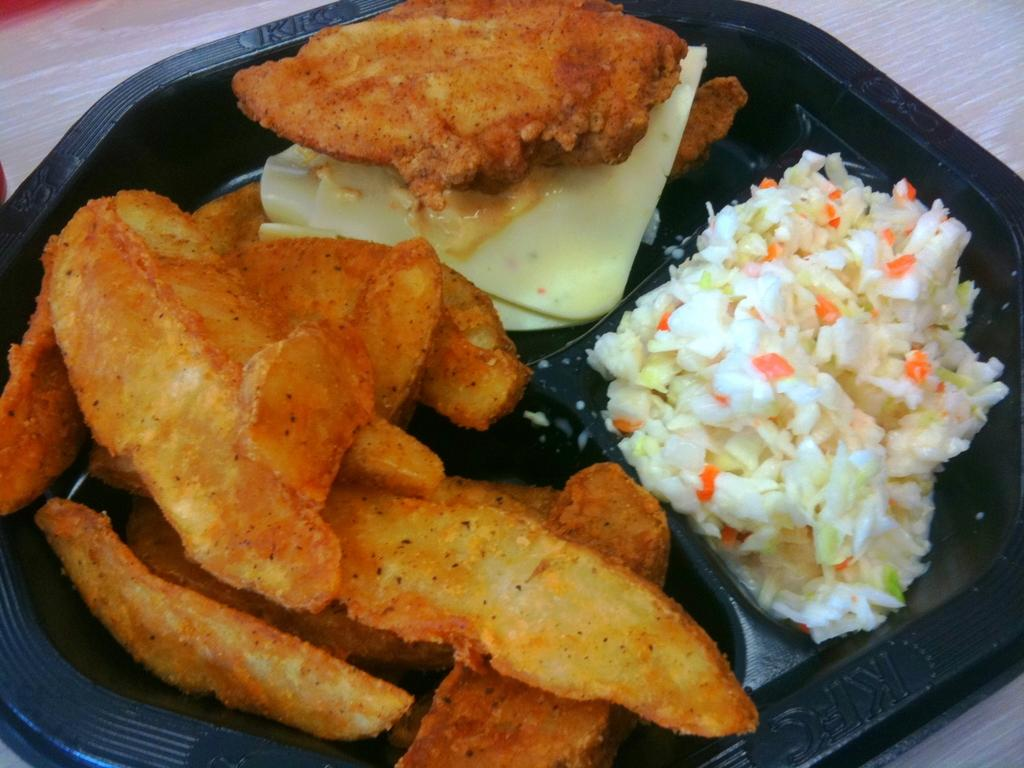What is present in the image related to food? There is food in the image. How is the food arranged or contained? The food is in a plate. Where is the plate with food located? The plate is placed on a surface. What type of pollution can be seen in the image? There is no pollution present in the image; it features food in a plate on a surface. What word is written on the plate in the image? There is no word written on the plate in the image. 